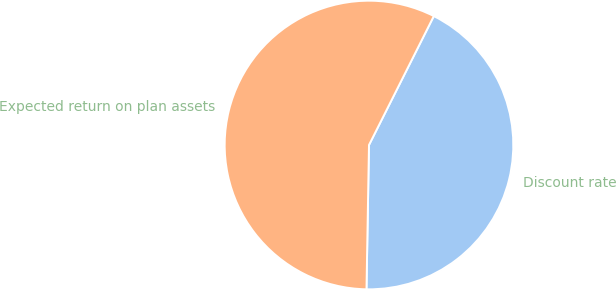Convert chart to OTSL. <chart><loc_0><loc_0><loc_500><loc_500><pie_chart><fcel>Discount rate<fcel>Expected return on plan assets<nl><fcel>42.86%<fcel>57.14%<nl></chart> 